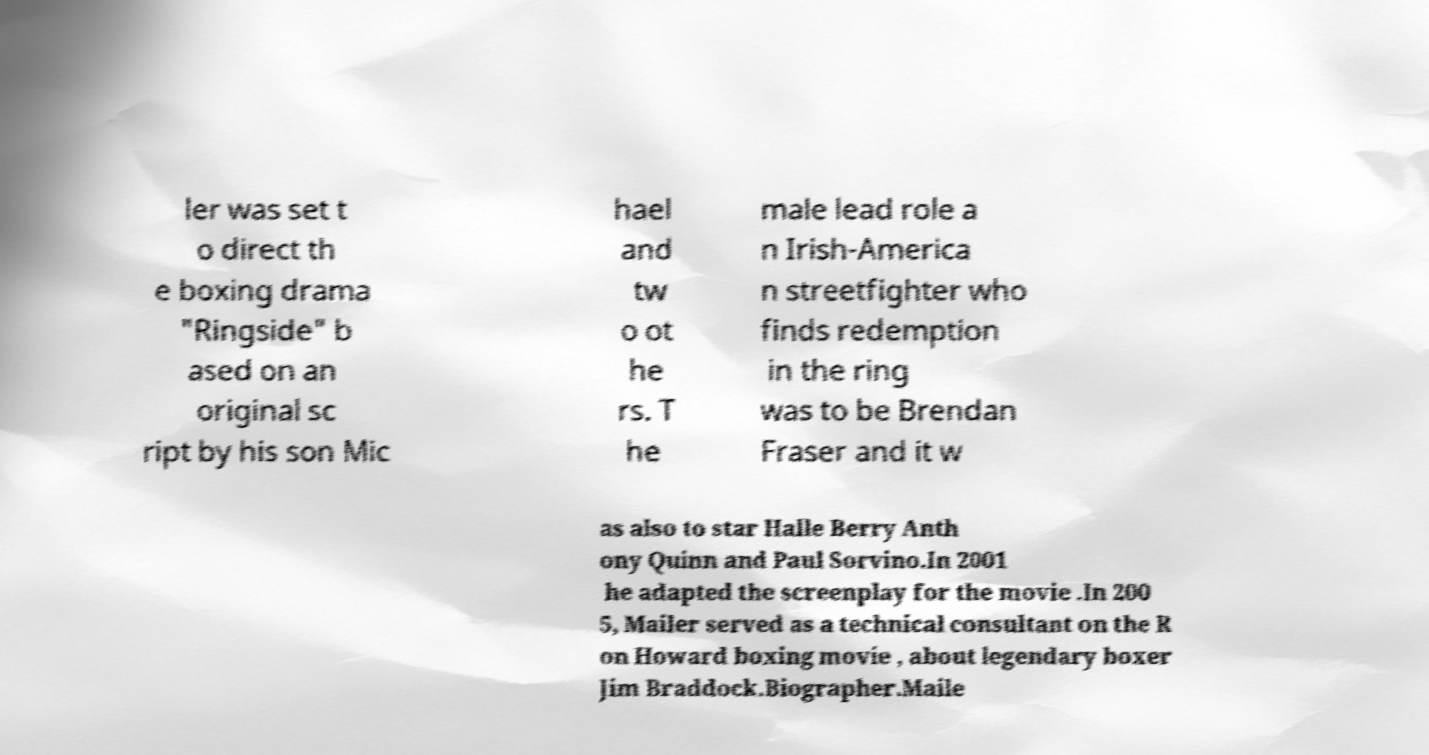Could you assist in decoding the text presented in this image and type it out clearly? ler was set t o direct th e boxing drama "Ringside" b ased on an original sc ript by his son Mic hael and tw o ot he rs. T he male lead role a n Irish-America n streetfighter who finds redemption in the ring was to be Brendan Fraser and it w as also to star Halle Berry Anth ony Quinn and Paul Sorvino.In 2001 he adapted the screenplay for the movie .In 200 5, Mailer served as a technical consultant on the R on Howard boxing movie , about legendary boxer Jim Braddock.Biographer.Maile 